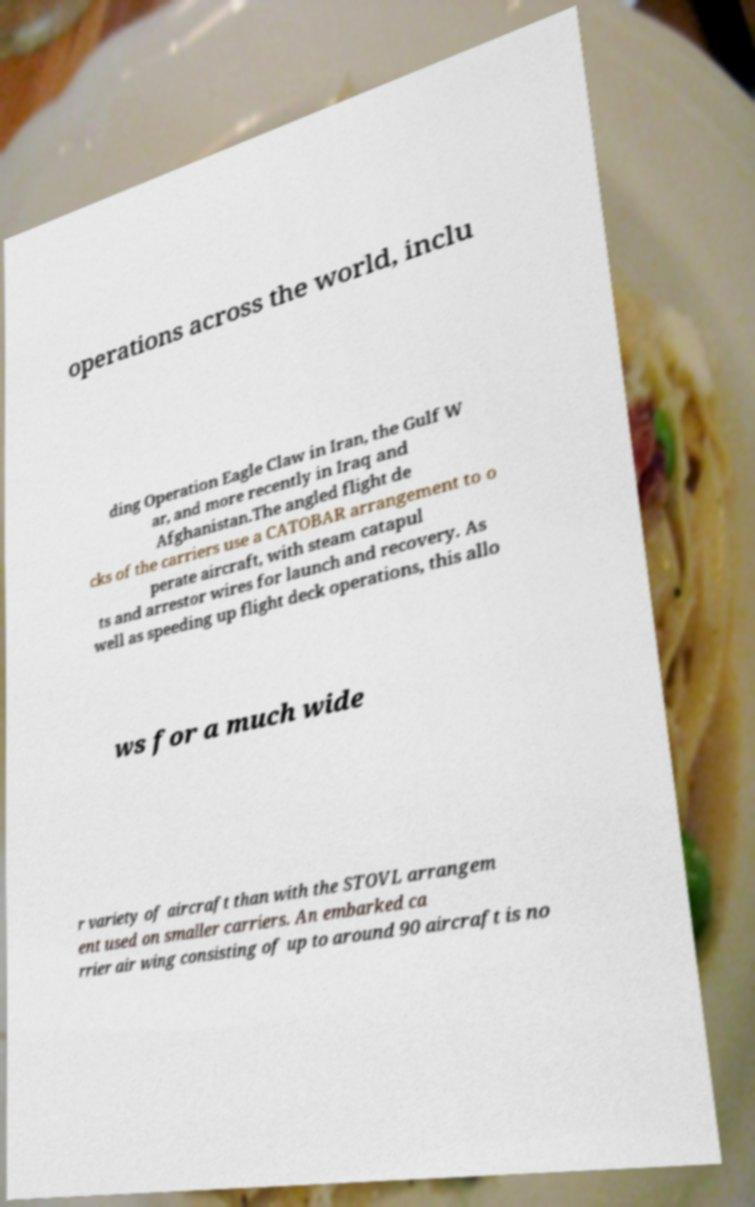Could you assist in decoding the text presented in this image and type it out clearly? operations across the world, inclu ding Operation Eagle Claw in Iran, the Gulf W ar, and more recently in Iraq and Afghanistan.The angled flight de cks of the carriers use a CATOBAR arrangement to o perate aircraft, with steam catapul ts and arrestor wires for launch and recovery. As well as speeding up flight deck operations, this allo ws for a much wide r variety of aircraft than with the STOVL arrangem ent used on smaller carriers. An embarked ca rrier air wing consisting of up to around 90 aircraft is no 